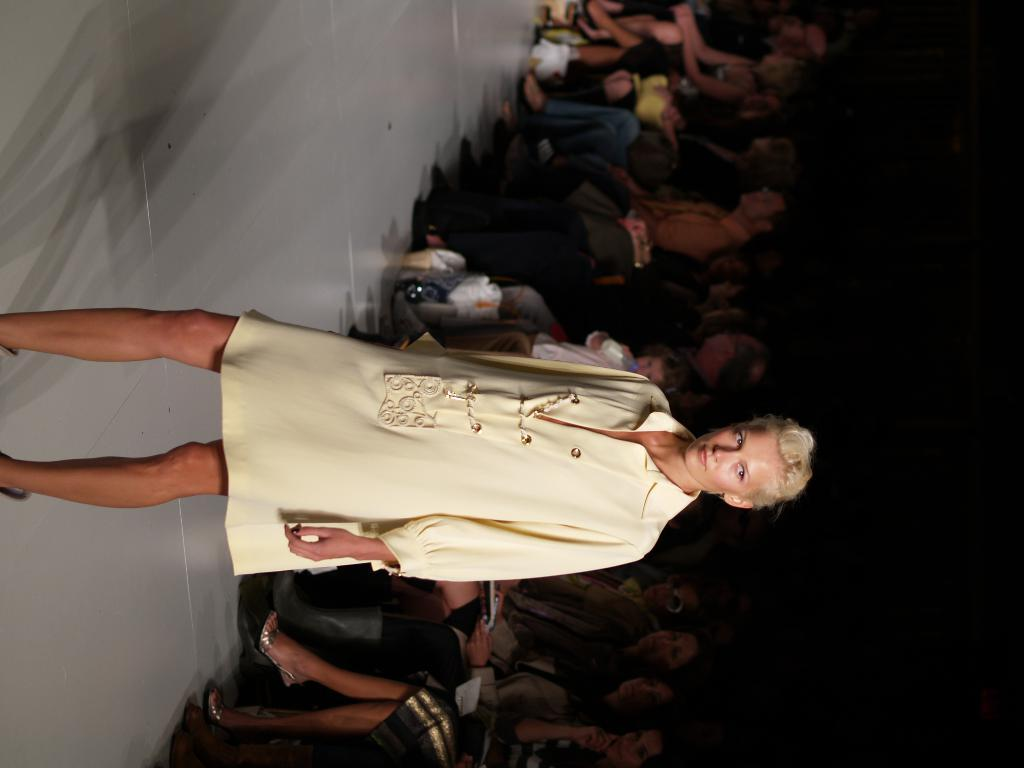What is the main subject of the image? There is a woman standing in the image. What is the woman's position in relation to the floor? The woman is standing on the floor. What can be seen in the background of the image? There is a group of people visible in the background, along with objects. How would you describe the lighting in the image? The background of the image is dark. What type of gold vein can be seen in the image? A: There is no gold vein present in the image. Is there a flame visible in the image? There is no flame visible in the image. 